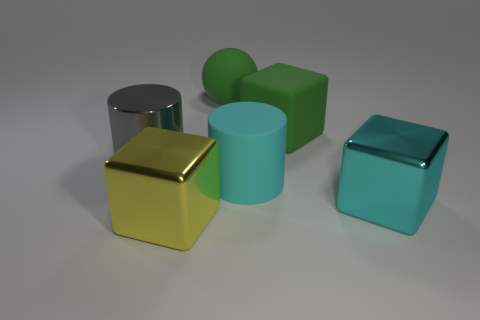Subtract all big shiny cubes. How many cubes are left? 1 Add 1 green matte things. How many objects exist? 7 Subtract all gray cylinders. How many cylinders are left? 1 Subtract all cylinders. How many objects are left? 4 Add 4 cyan metallic objects. How many cyan metallic objects are left? 5 Add 4 large yellow objects. How many large yellow objects exist? 5 Subtract 1 cyan cylinders. How many objects are left? 5 Subtract 1 spheres. How many spheres are left? 0 Subtract all blue balls. Subtract all purple blocks. How many balls are left? 1 Subtract all blue metal cubes. Subtract all cyan rubber cylinders. How many objects are left? 5 